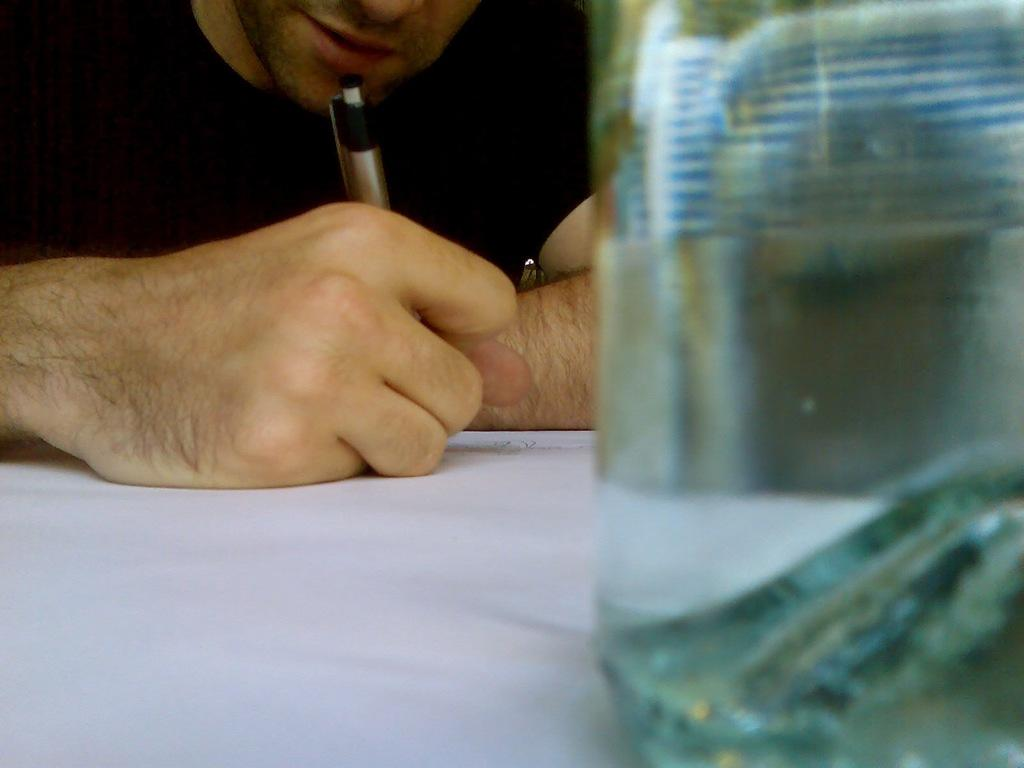What is present in the image? There is a person in the image. What is the person holding in the image? The person is holding a pen. What type of flooring can be seen under the person in the image? There is no information about the flooring in the image. Is the person wearing a scarf in the image? There is no mention of a scarf in the image. Is the person wearing a mask in the image? There is no mention of a mask in the image. 